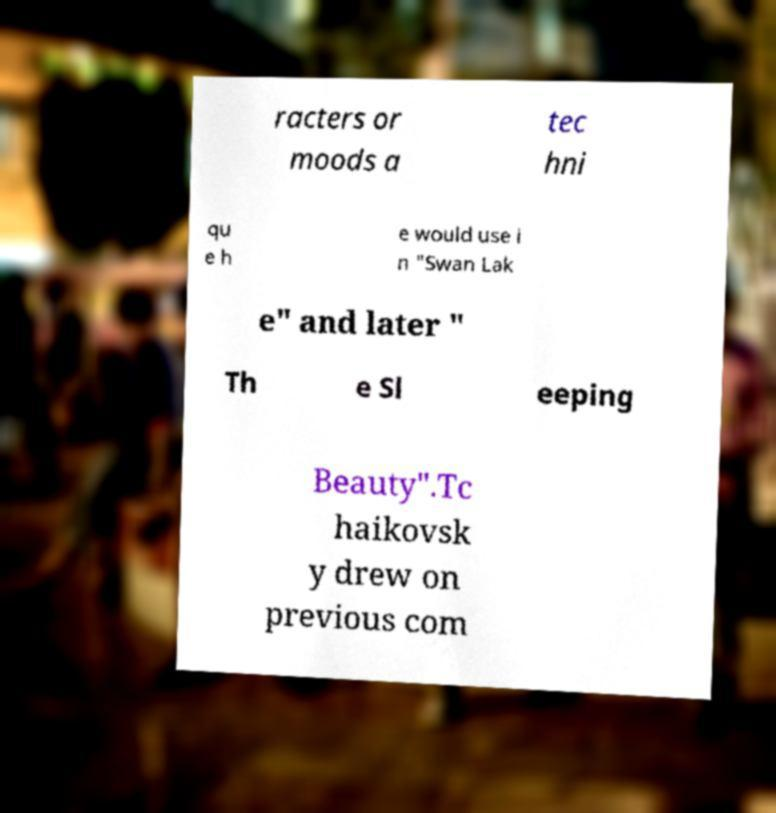What messages or text are displayed in this image? I need them in a readable, typed format. racters or moods a tec hni qu e h e would use i n "Swan Lak e" and later " Th e Sl eeping Beauty".Tc haikovsk y drew on previous com 